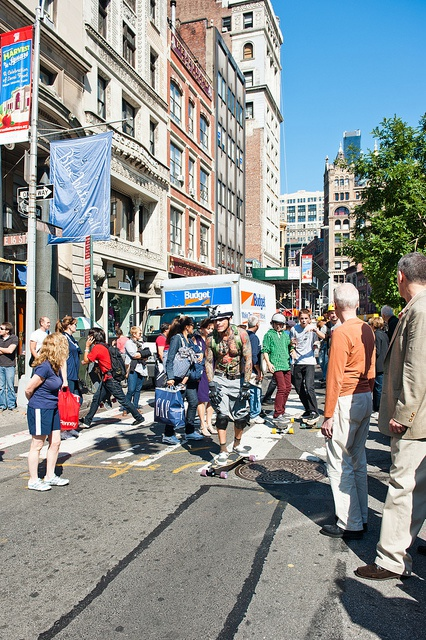Describe the objects in this image and their specific colors. I can see people in black, white, gray, and salmon tones, people in black, lightgray, gray, and darkgray tones, people in black, gray, blue, and lightgray tones, truck in black, white, and gray tones, and people in black, lightgray, gray, and darkgray tones in this image. 